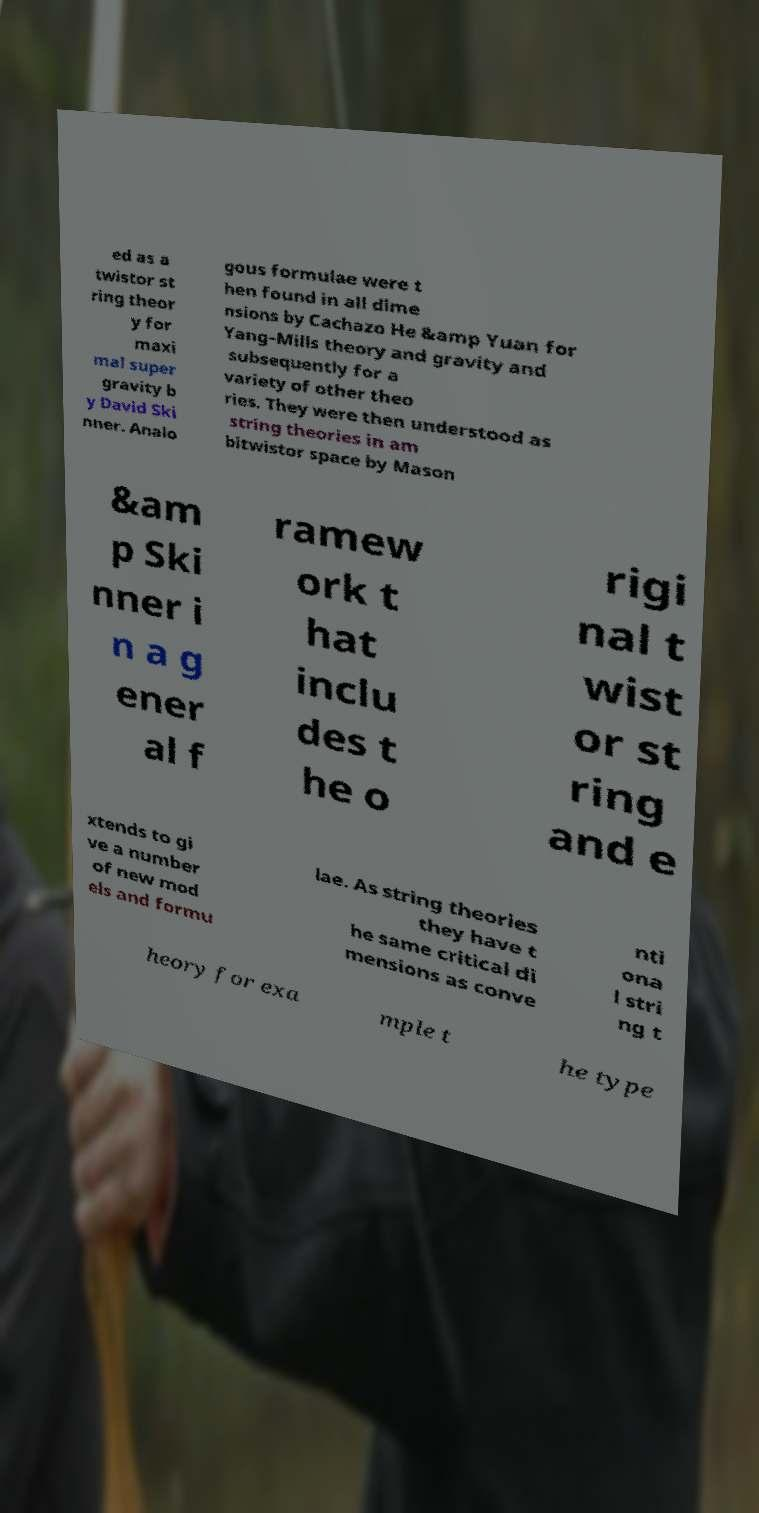Can you read and provide the text displayed in the image?This photo seems to have some interesting text. Can you extract and type it out for me? ed as a twistor st ring theor y for maxi mal super gravity b y David Ski nner. Analo gous formulae were t hen found in all dime nsions by Cachazo He &amp Yuan for Yang–Mills theory and gravity and subsequently for a variety of other theo ries. They were then understood as string theories in am bitwistor space by Mason &am p Ski nner i n a g ener al f ramew ork t hat inclu des t he o rigi nal t wist or st ring and e xtends to gi ve a number of new mod els and formu lae. As string theories they have t he same critical di mensions as conve nti ona l stri ng t heory for exa mple t he type 